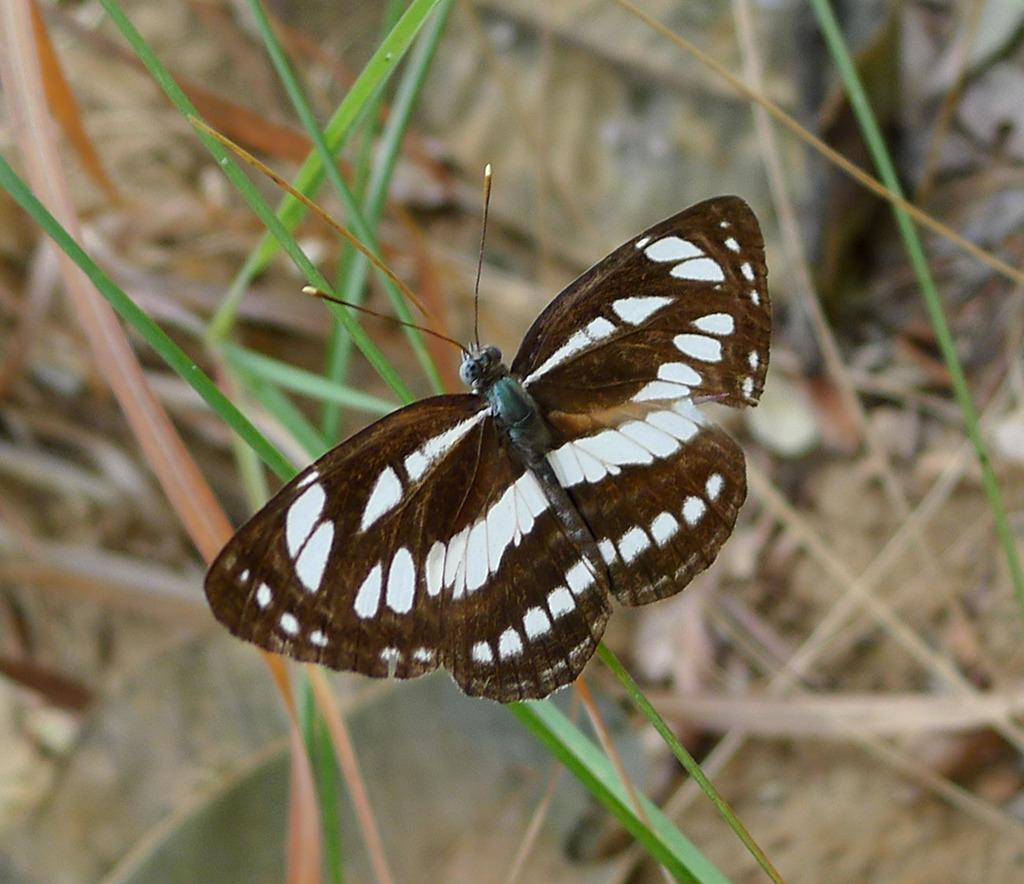What is the main subject of the picture? The main subject of the picture is a butterfly. Where is the butterfly located in the image? The butterfly is on the grass. What colors can be seen on the butterfly? The butterfly is white and brown in color. What type of muscle is visible in the image? There is no muscle visible in the image; it features a butterfly on the grass. Can you tell me how many members are in the committee shown in the image? There is no committee present in the image; it features a butterfly on the grass. 